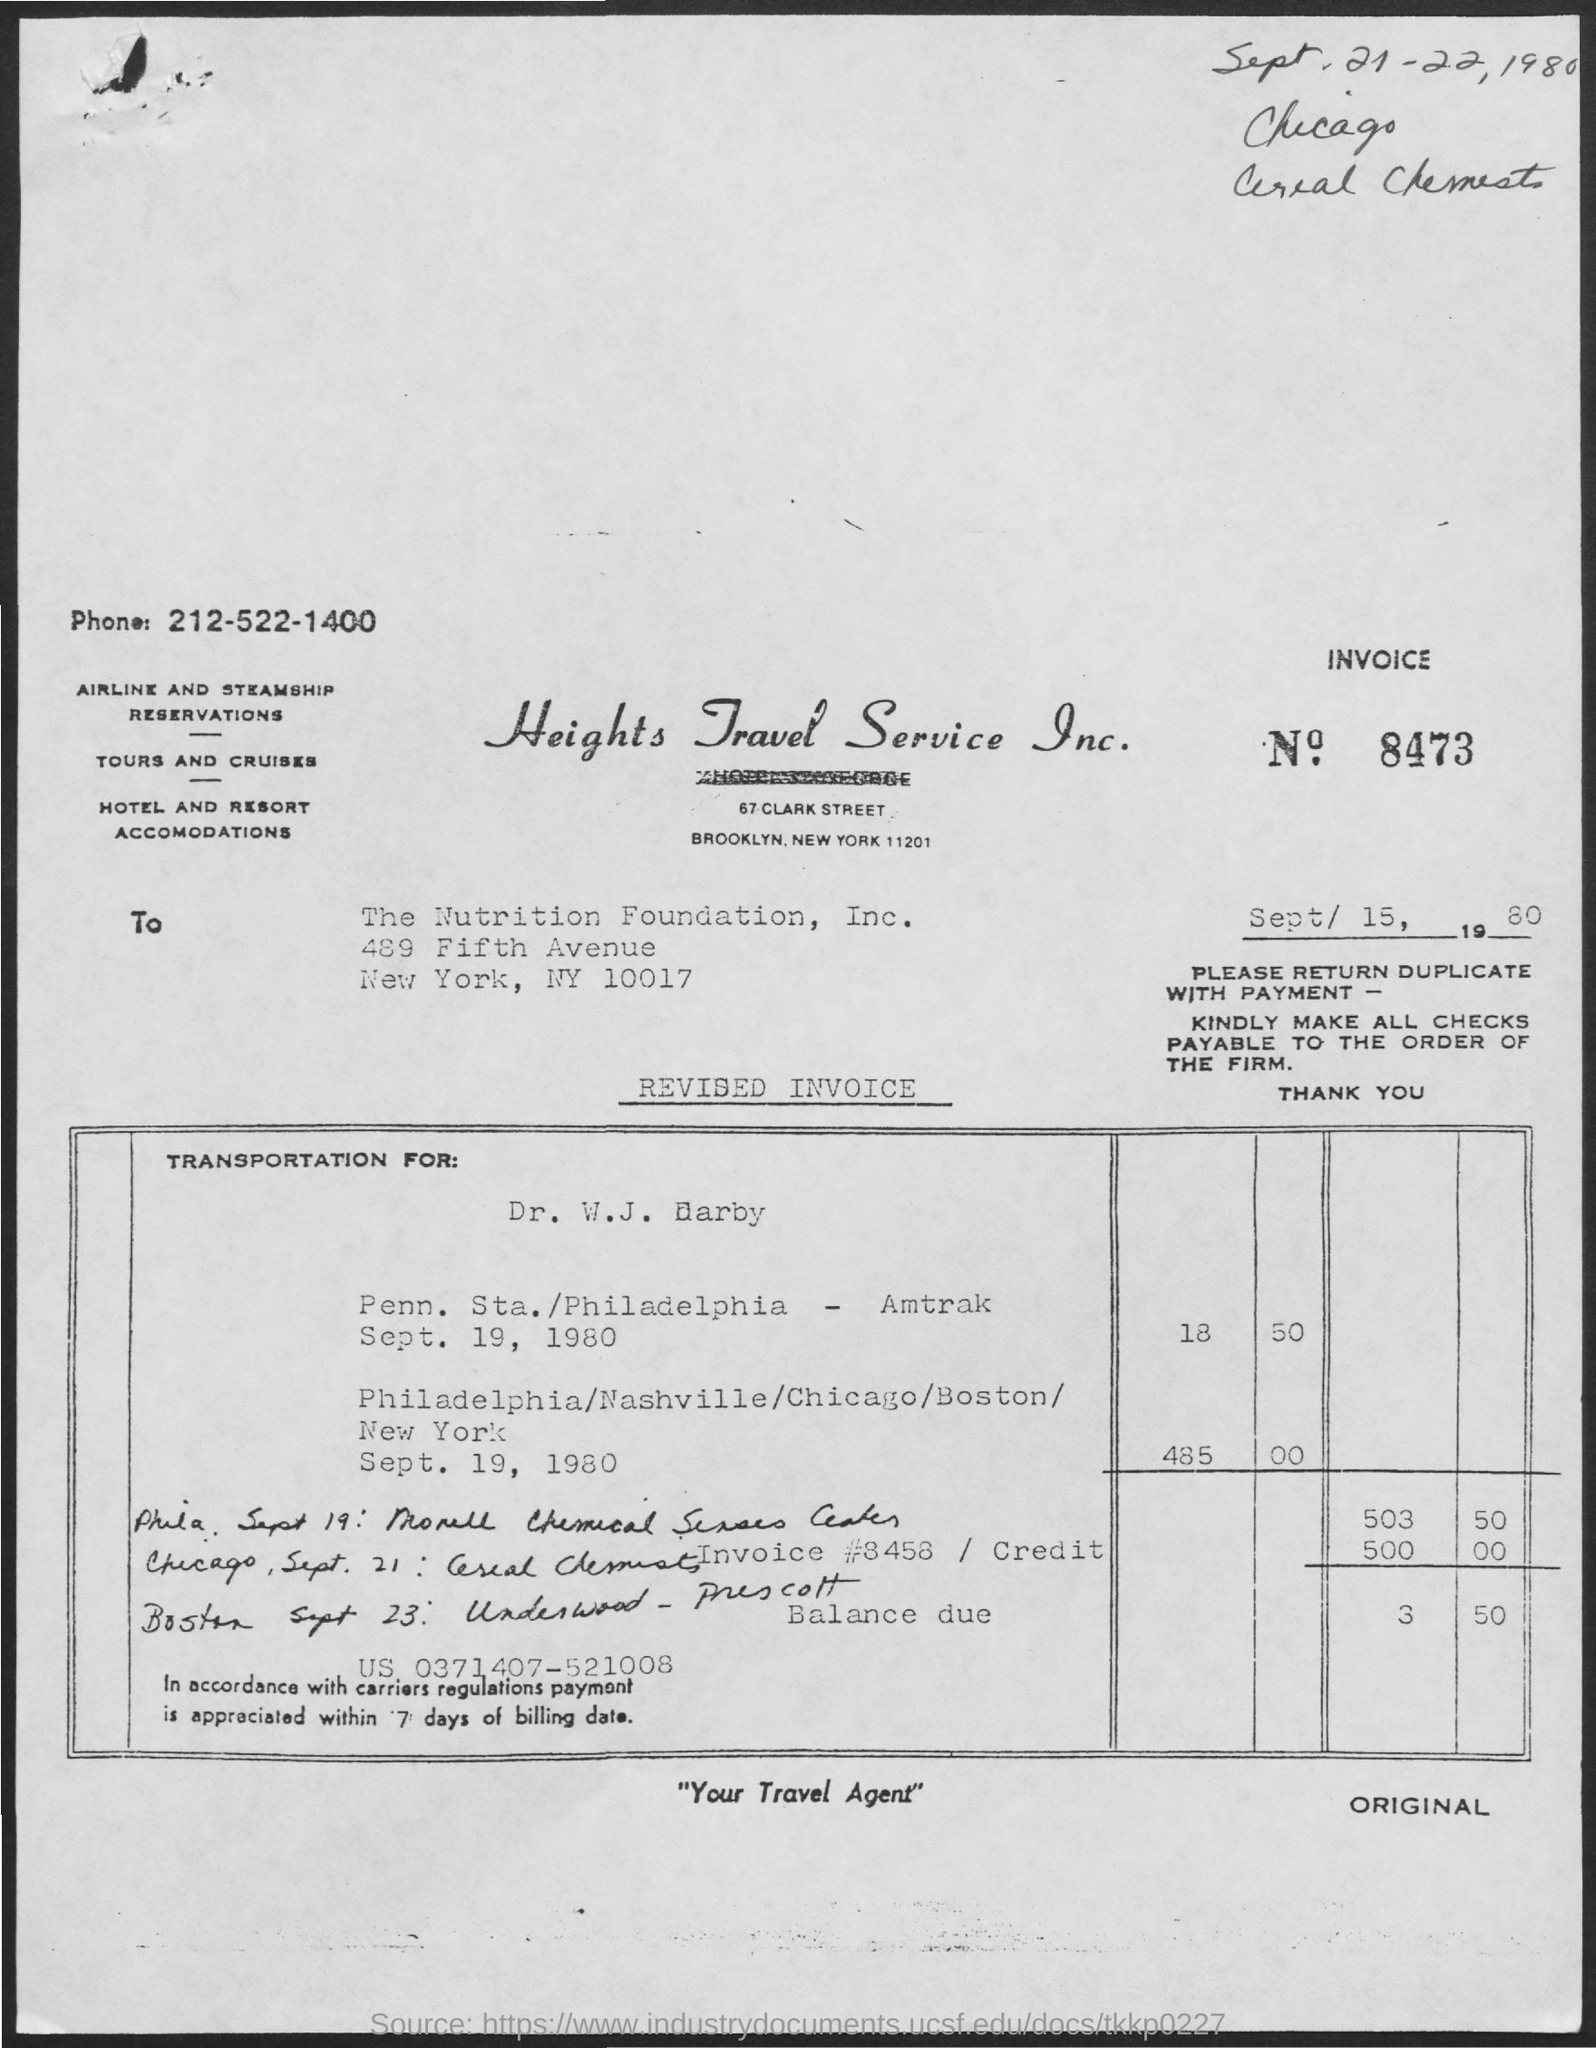What is the Invoice Number?
Provide a short and direct response. 8473. What is the date below the invoice number?
Provide a succinct answer. Sept/ 15, 1980. What is the handwritten date at the top right of the document?
Your answer should be compact. Sept.21-22,1980. 